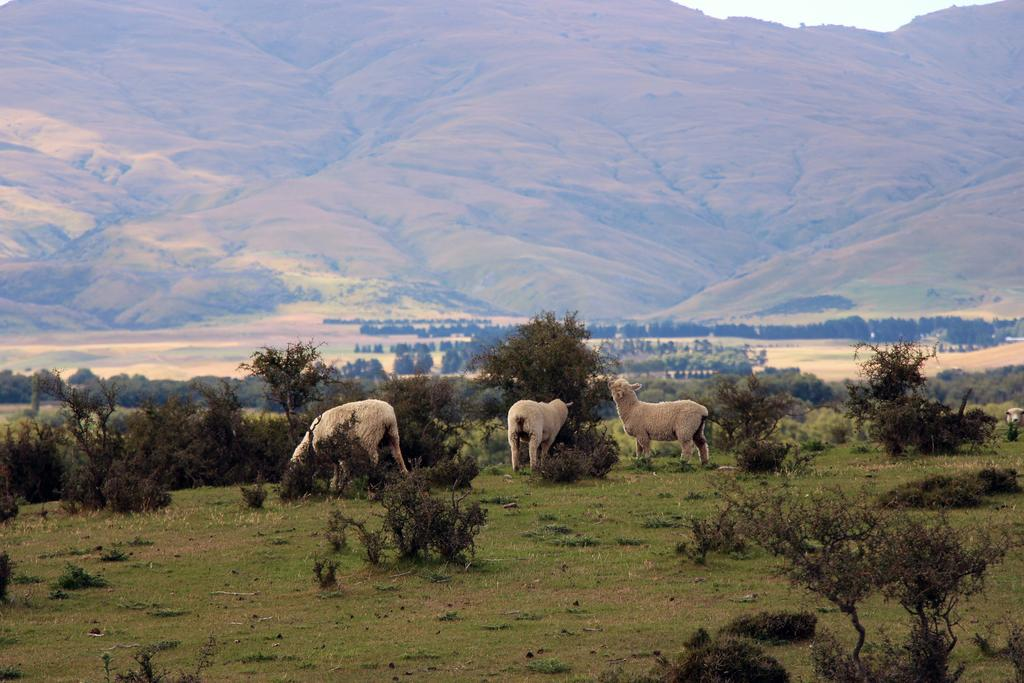How many animals can be seen in the image? There are three animals in the image. What else is present in the image besides the animals? There are plants and grass visible in the image. What can be seen in the background of the image? There are trees and mountains in the background of the image. What type of pest is causing problems for the animals in the image? There is no indication of any pest causing problems for the animals in the image. Can you describe the zephyr blowing through the image? There is no mention of a zephyr or any wind in the image. 